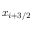<formula> <loc_0><loc_0><loc_500><loc_500>x _ { i + 3 / 2 }</formula> 